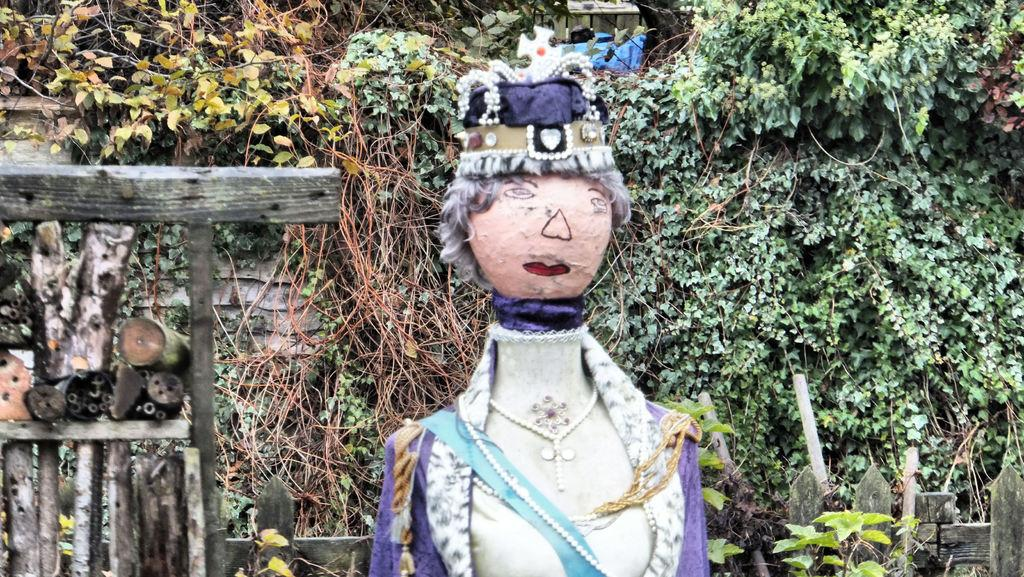What is the main subject of the image? There is a scarecrow in the image. What can be seen in the background of the image? There are plants and wooden objects in the background of the image. What hobbies does the scarecrow have, and how does it express its interests in the image? There is no information about the scarecrow's hobbies or interests in the image. 